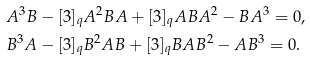Convert formula to latex. <formula><loc_0><loc_0><loc_500><loc_500>& A ^ { 3 } B - [ 3 ] _ { q } A ^ { 2 } B A + [ 3 ] _ { q } A B A ^ { 2 } - B A ^ { 3 } = 0 , \\ & B ^ { 3 } A - [ 3 ] _ { q } B ^ { 2 } A B + [ 3 ] _ { q } B A B ^ { 2 } - A B ^ { 3 } = 0 .</formula> 